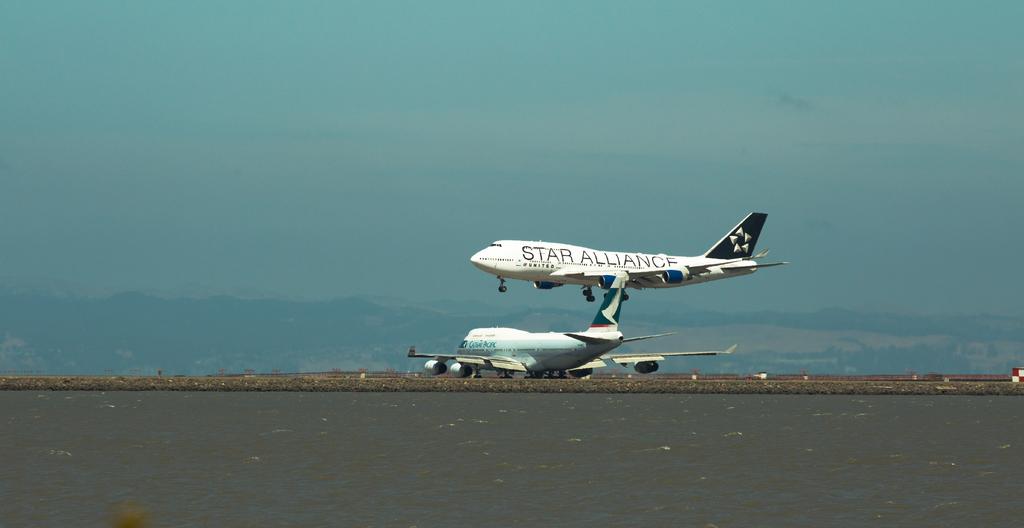What does the flying plane say?
Offer a very short reply. Star alliance. 